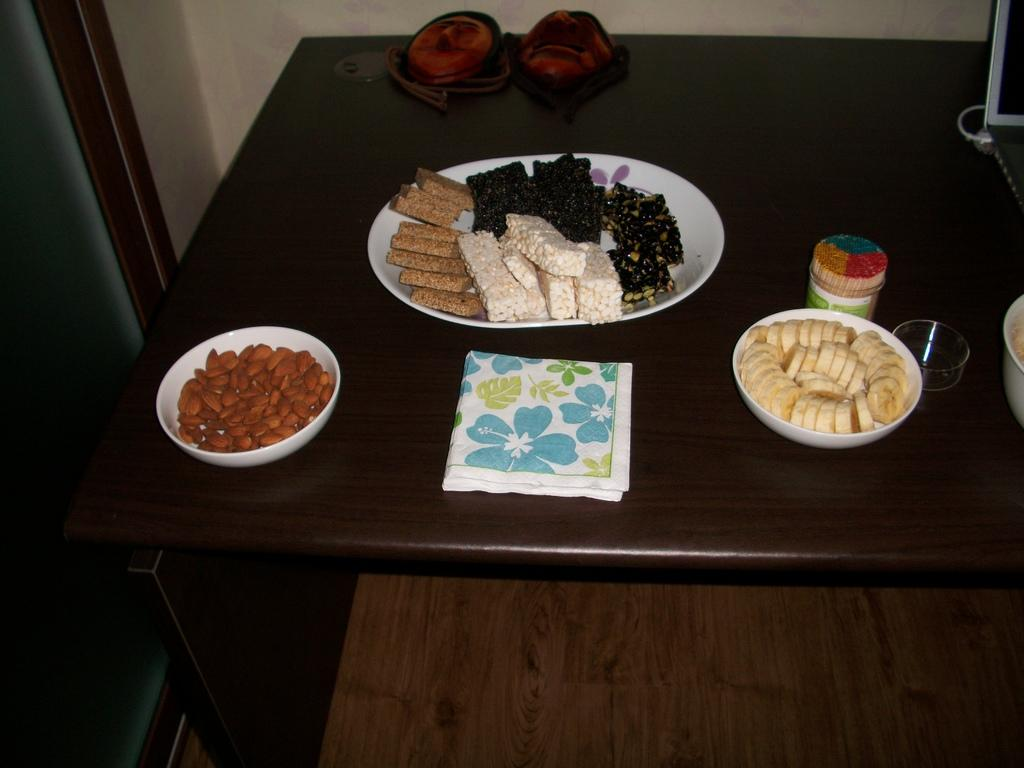What piece of furniture is present in the image? There is a table in the image. What is on the table? There is a plate with food items, a bowl with almonds, fruits, and a napkin on the table. What type of food items can be seen on the plate? The facts do not specify the type of food items on the plate. How many bowls are visible on the table? There is one bowl visible on the table, which contains almonds. Where is the cork placed in the image? There is no cork present in the image. Is there a fire burning on the table in the image? No, there is no fire present in the image. 